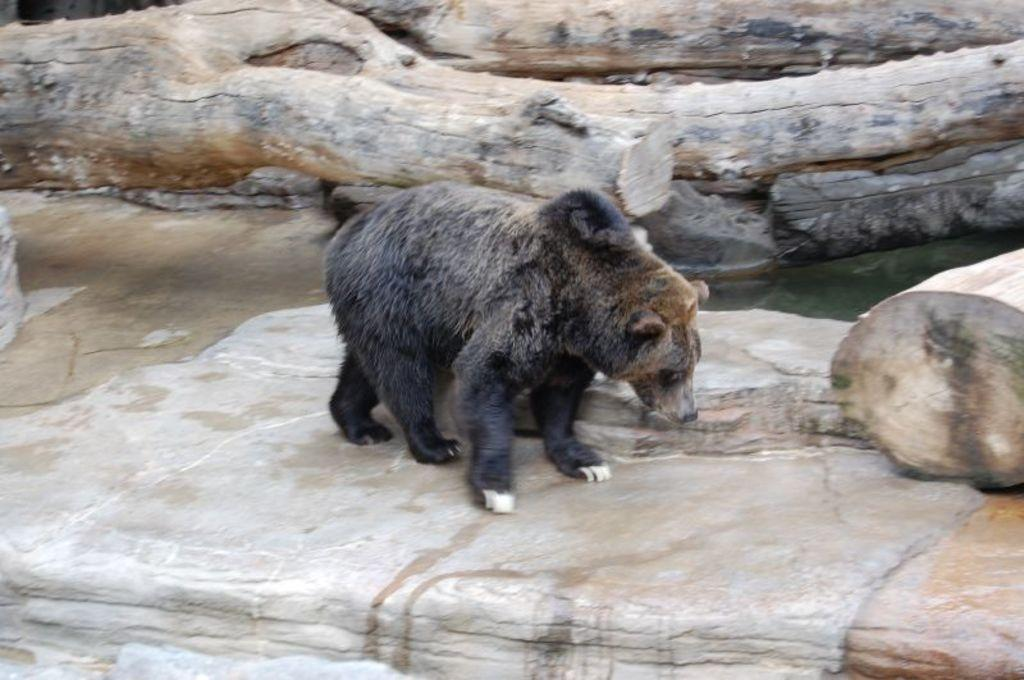What animal is in the picture? There is a bear in the picture. Where is the bear located? The bear is on a rock. What can be seen in the background of the image? There are wooden logs in the background of the image. What type of locket is the bear holding in the image? There is no locket present in the image; the bear is simply on a rock. 